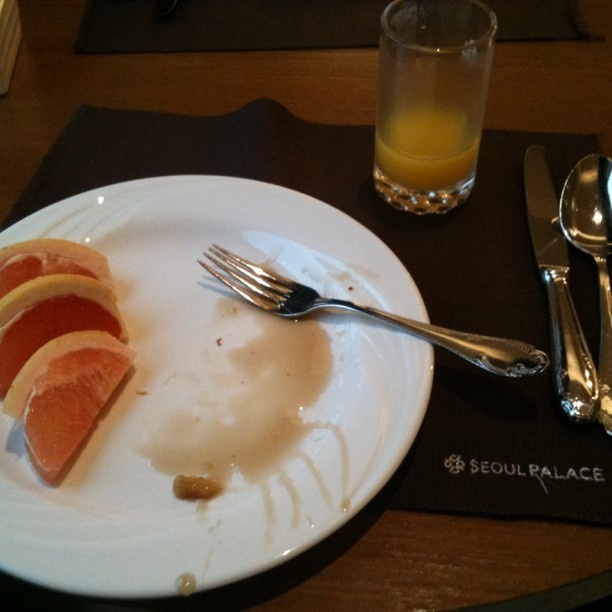Describe the objects in this image and their specific colors. I can see dining table in black, darkgray, maroon, tan, and olive tones, cup in olive, maroon, and black tones, knife in olive, black, maroon, and gray tones, orange in olive, brown, and maroon tones, and orange in olive, maroon, brown, and tan tones in this image. 